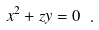Convert formula to latex. <formula><loc_0><loc_0><loc_500><loc_500>x ^ { 2 } + z y = 0 \ .</formula> 